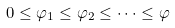Convert formula to latex. <formula><loc_0><loc_0><loc_500><loc_500>0 \leq \varphi _ { 1 } \leq \varphi _ { 2 } \leq \dots \leq \varphi</formula> 